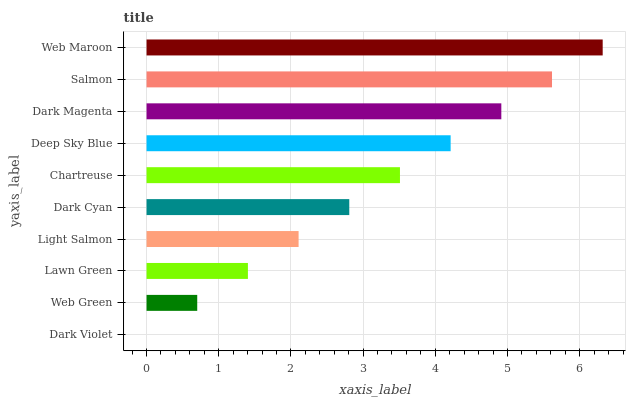Is Dark Violet the minimum?
Answer yes or no. Yes. Is Web Maroon the maximum?
Answer yes or no. Yes. Is Web Green the minimum?
Answer yes or no. No. Is Web Green the maximum?
Answer yes or no. No. Is Web Green greater than Dark Violet?
Answer yes or no. Yes. Is Dark Violet less than Web Green?
Answer yes or no. Yes. Is Dark Violet greater than Web Green?
Answer yes or no. No. Is Web Green less than Dark Violet?
Answer yes or no. No. Is Chartreuse the high median?
Answer yes or no. Yes. Is Dark Cyan the low median?
Answer yes or no. Yes. Is Dark Cyan the high median?
Answer yes or no. No. Is Lawn Green the low median?
Answer yes or no. No. 